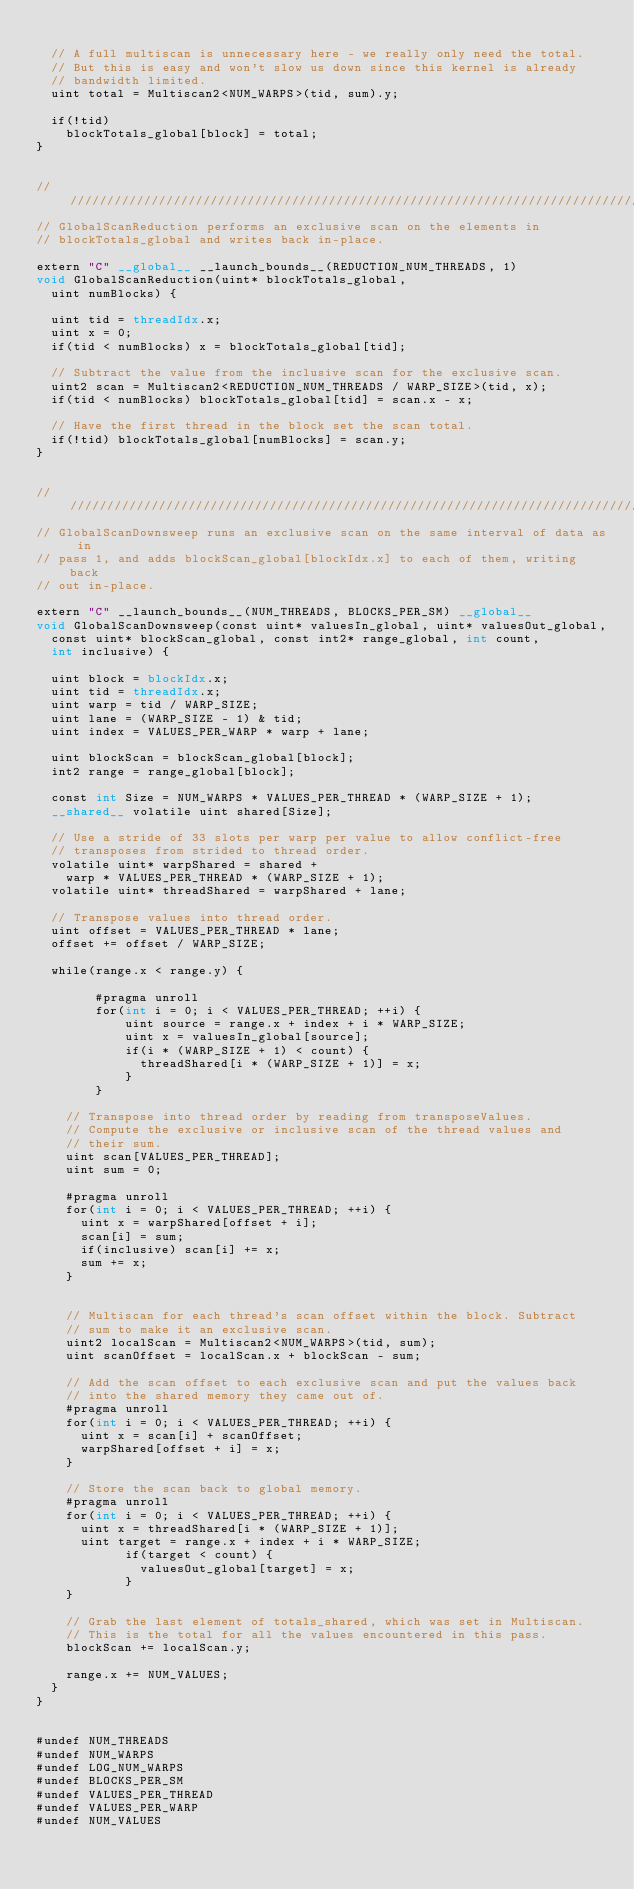<code> <loc_0><loc_0><loc_500><loc_500><_Cuda_>
	// A full multiscan is unnecessary here - we really only need the total.
	// But this is easy and won't slow us down since this kernel is already
	// bandwidth limited.
	uint total = Multiscan2<NUM_WARPS>(tid, sum).y;

	if(!tid)
		blockTotals_global[block] = total;
}


////////////////////////////////////////////////////////////////////////////////
// GlobalScanReduction performs an exclusive scan on the elements in 
// blockTotals_global and writes back in-place.

extern "C" __global__ __launch_bounds__(REDUCTION_NUM_THREADS, 1)
void GlobalScanReduction(uint* blockTotals_global, 
	uint numBlocks) {

	uint tid = threadIdx.x;
	uint x = 0; 
	if(tid < numBlocks) x = blockTotals_global[tid];

	// Subtract the value from the inclusive scan for the exclusive scan.
	uint2 scan = Multiscan2<REDUCTION_NUM_THREADS / WARP_SIZE>(tid, x);
	if(tid < numBlocks) blockTotals_global[tid] = scan.x - x;

	// Have the first thread in the block set the scan total.
	if(!tid) blockTotals_global[numBlocks] = scan.y;
}


////////////////////////////////////////////////////////////////////////////////
// GlobalScanDownsweep runs an exclusive scan on the same interval of data as in
// pass 1, and adds blockScan_global[blockIdx.x] to each of them, writing back
// out in-place.

extern "C" __launch_bounds__(NUM_THREADS, BLOCKS_PER_SM) __global__ 
void GlobalScanDownsweep(const uint* valuesIn_global, uint* valuesOut_global,
	const uint* blockScan_global, const int2* range_global, int count, 
	int inclusive) {

	uint block = blockIdx.x;
	uint tid = threadIdx.x;
	uint warp = tid / WARP_SIZE;
	uint lane = (WARP_SIZE - 1) & tid;
	uint index = VALUES_PER_WARP * warp + lane;

	uint blockScan = blockScan_global[block];
	int2 range = range_global[block];

	const int Size = NUM_WARPS * VALUES_PER_THREAD * (WARP_SIZE + 1);
	__shared__ volatile uint shared[Size];

	// Use a stride of 33 slots per warp per value to allow conflict-free
	// transposes from strided to thread order.
	volatile uint* warpShared = shared + 
		warp * VALUES_PER_THREAD * (WARP_SIZE + 1);
	volatile uint* threadShared = warpShared + lane;

	// Transpose values into thread order.
	uint offset = VALUES_PER_THREAD * lane;
	offset += offset / WARP_SIZE;

	while(range.x < range.y) {

        #pragma unroll
        for(int i = 0; i < VALUES_PER_THREAD; ++i) {
            uint source = range.x + index + i * WARP_SIZE;
            uint x = valuesIn_global[source];
            if(i * (WARP_SIZE + 1) < count) {
              threadShared[i * (WARP_SIZE + 1)] = x;
            }
        }

		// Transpose into thread order by reading from transposeValues.
		// Compute the exclusive or inclusive scan of the thread values and 
		// their sum.
		uint scan[VALUES_PER_THREAD];
		uint sum = 0;
	
		#pragma unroll
		for(int i = 0; i < VALUES_PER_THREAD; ++i) {
			uint x = warpShared[offset + i];
			scan[i] = sum;
			if(inclusive) scan[i] += x;
			sum += x;
		}


		// Multiscan for each thread's scan offset within the block. Subtract
		// sum to make it an exclusive scan.
		uint2 localScan = Multiscan2<NUM_WARPS>(tid, sum);
		uint scanOffset = localScan.x + blockScan - sum;

		// Add the scan offset to each exclusive scan and put the values back
		// into the shared memory they came out of.
		#pragma unroll
		for(int i = 0; i < VALUES_PER_THREAD; ++i) {
			uint x = scan[i] + scanOffset;
			warpShared[offset + i] = x;
		}

		// Store the scan back to global memory.
		#pragma unroll
		for(int i = 0; i < VALUES_PER_THREAD; ++i) {
			uint x = threadShared[i * (WARP_SIZE + 1)];
			uint target = range.x + index + i * WARP_SIZE;
            if(target < count) {
              valuesOut_global[target] = x;
            }
		}

		// Grab the last element of totals_shared, which was set in Multiscan.
		// This is the total for all the values encountered in this pass.
		blockScan += localScan.y;

		range.x += NUM_VALUES;
	}
}


#undef NUM_THREADS
#undef NUM_WARPS
#undef LOG_NUM_WARPS
#undef BLOCKS_PER_SM
#undef VALUES_PER_THREAD
#undef VALUES_PER_WARP
#undef NUM_VALUES
</code> 